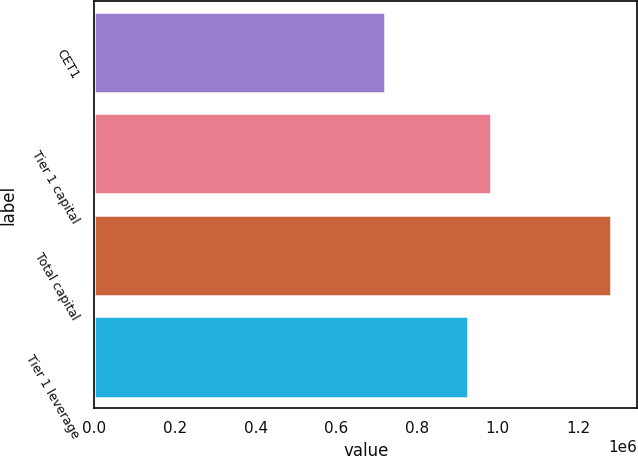Convert chart. <chart><loc_0><loc_0><loc_500><loc_500><bar_chart><fcel>CET1<fcel>Tier 1 capital<fcel>Total capital<fcel>Tier 1 leverage<nl><fcel>721112<fcel>982477<fcel>1.28198e+06<fcel>926390<nl></chart> 